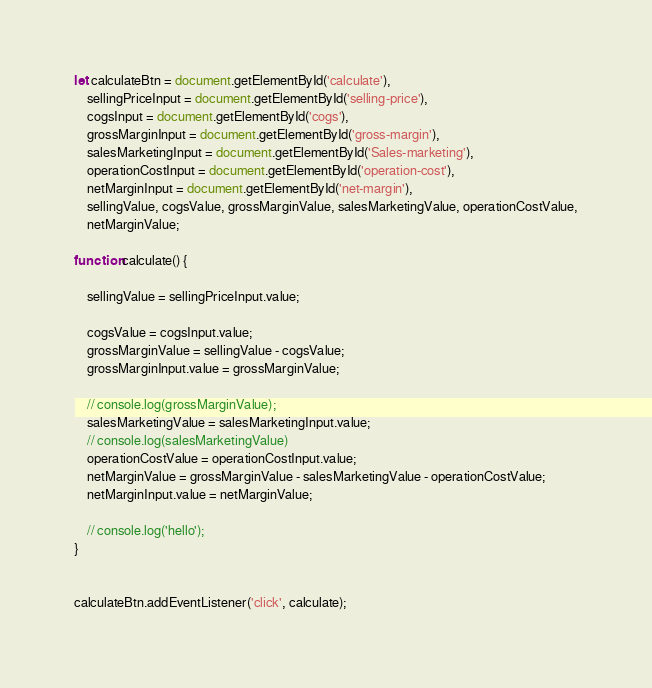<code> <loc_0><loc_0><loc_500><loc_500><_JavaScript_>let calculateBtn = document.getElementById('calculate'),
    sellingPriceInput = document.getElementById('selling-price'),
    cogsInput = document.getElementById('cogs'),
    grossMarginInput = document.getElementById('gross-margin'),
    salesMarketingInput = document.getElementById('Sales-marketing'),
    operationCostInput = document.getElementById('operation-cost'),
    netMarginInput = document.getElementById('net-margin'),
    sellingValue, cogsValue, grossMarginValue, salesMarketingValue, operationCostValue,
    netMarginValue;

function calculate() {

    sellingValue = sellingPriceInput.value;

    cogsValue = cogsInput.value;
    grossMarginValue = sellingValue - cogsValue;
    grossMarginInput.value = grossMarginValue;

    // console.log(grossMarginValue);
    salesMarketingValue = salesMarketingInput.value;
    // console.log(salesMarketingValue)
    operationCostValue = operationCostInput.value;
    netMarginValue = grossMarginValue - salesMarketingValue - operationCostValue;
    netMarginInput.value = netMarginValue;    

    // console.log('hello');
}


calculateBtn.addEventListener('click', calculate);

</code> 